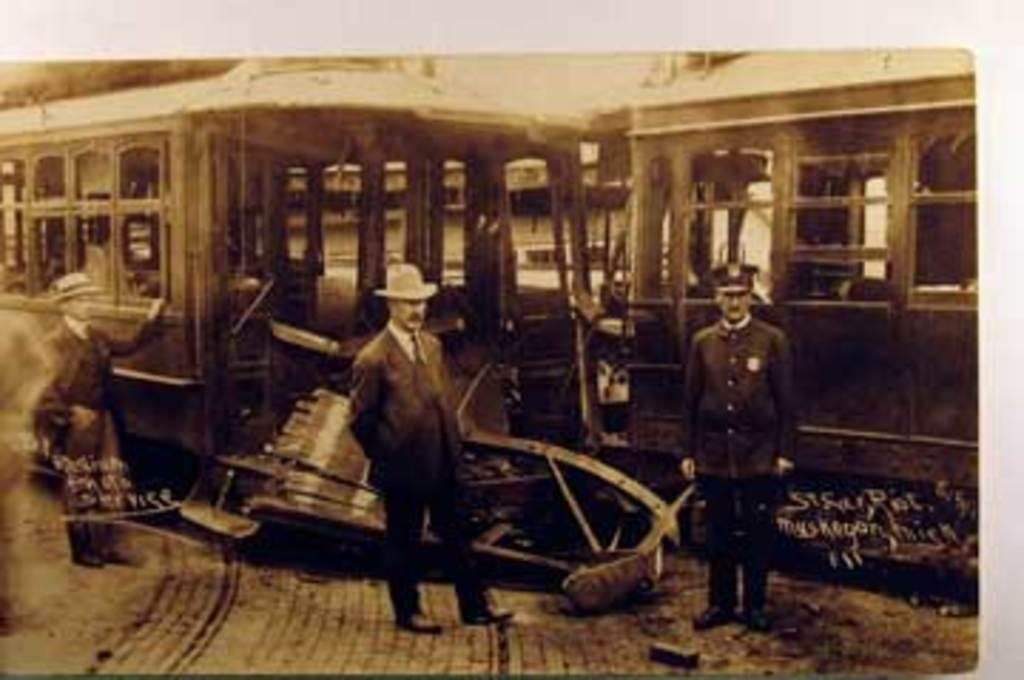What is the color scheme of the image? The image is black and white. What can be seen in the foreground of the image? There are people in the foreground of the image. What is located in the background of the image? There is a locomotive in the background of the image. How much rice is being cooked by the people in the image? There is no rice present in the image, as it is a black and white image featuring people in the foreground and a locomotive in the background. 